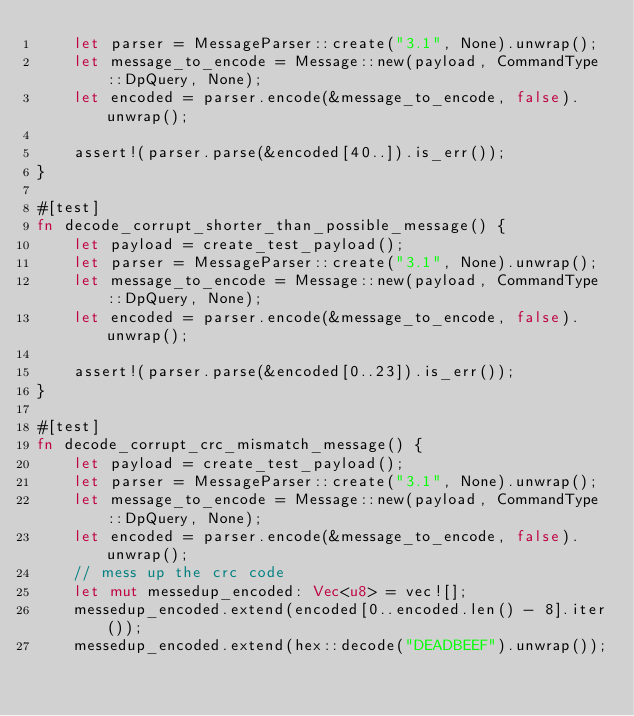<code> <loc_0><loc_0><loc_500><loc_500><_Rust_>    let parser = MessageParser::create("3.1", None).unwrap();
    let message_to_encode = Message::new(payload, CommandType::DpQuery, None);
    let encoded = parser.encode(&message_to_encode, false).unwrap();

    assert!(parser.parse(&encoded[40..]).is_err());
}

#[test]
fn decode_corrupt_shorter_than_possible_message() {
    let payload = create_test_payload();
    let parser = MessageParser::create("3.1", None).unwrap();
    let message_to_encode = Message::new(payload, CommandType::DpQuery, None);
    let encoded = parser.encode(&message_to_encode, false).unwrap();

    assert!(parser.parse(&encoded[0..23]).is_err());
}

#[test]
fn decode_corrupt_crc_mismatch_message() {
    let payload = create_test_payload();
    let parser = MessageParser::create("3.1", None).unwrap();
    let message_to_encode = Message::new(payload, CommandType::DpQuery, None);
    let encoded = parser.encode(&message_to_encode, false).unwrap();
    // mess up the crc code
    let mut messedup_encoded: Vec<u8> = vec![];
    messedup_encoded.extend(encoded[0..encoded.len() - 8].iter());
    messedup_encoded.extend(hex::decode("DEADBEEF").unwrap());</code> 